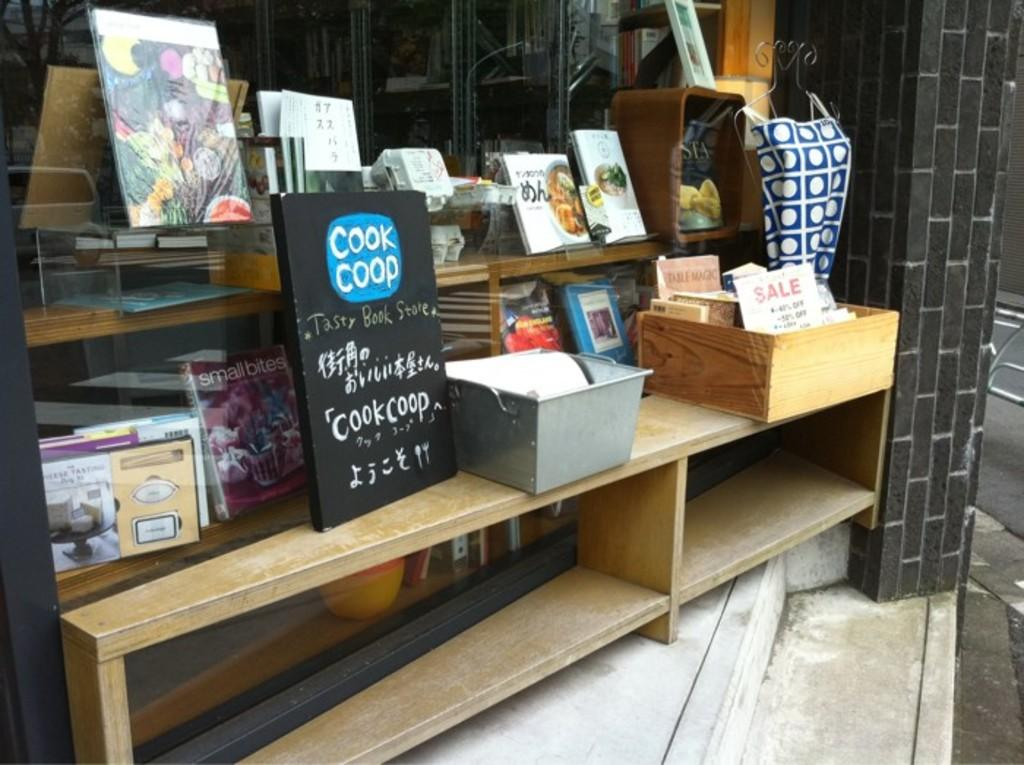What objects are on the table in the image? There are books, a blackboard, and boxes on the table. What might the blackboard be used for? The blackboard might be used for writing or drawing. How many types of objects are on the table? There are three types of objects on the table: books, a blackboard, and boxes. What type of doctor is standing next to the table in the image? There is no doctor present in the image; it only features objects on a table. How does the tramp contribute to the scene in the image? There is no tramp present in the image; it only features objects on a table. 